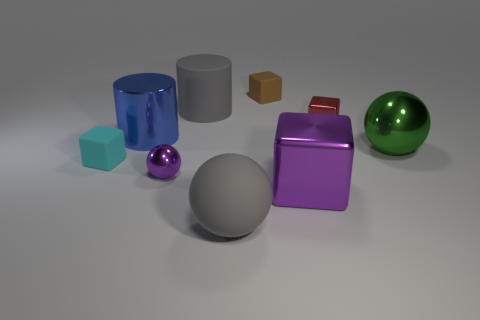Is the color of the large matte thing behind the tiny cyan thing the same as the rubber object that is in front of the purple ball?
Offer a terse response. Yes. How many other things are the same color as the big metal cylinder?
Your answer should be compact. 0. What material is the sphere on the right side of the tiny shiny thing that is right of the large gray matte sphere?
Ensure brevity in your answer.  Metal. There is a matte block that is behind the small cyan rubber block; does it have the same color as the matte cylinder?
Keep it short and to the point. No. Is there any other thing that is made of the same material as the green object?
Give a very brief answer. Yes. What number of other small cyan matte objects have the same shape as the cyan thing?
Ensure brevity in your answer.  0. There is a purple cube that is the same material as the blue thing; what is its size?
Provide a succinct answer. Large. There is a big gray matte thing to the left of the big sphere that is left of the tiny brown matte thing; is there a blue cylinder left of it?
Your response must be concise. Yes. There is a cylinder that is to the left of the gray cylinder; does it have the same size as the big metallic ball?
Your answer should be compact. Yes. How many green metal objects are the same size as the brown matte block?
Make the answer very short. 0. 